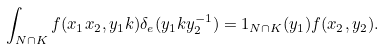Convert formula to latex. <formula><loc_0><loc_0><loc_500><loc_500>\int _ { N \cap K } f ( x _ { 1 } x _ { 2 } , y _ { 1 } k ) \delta _ { e } ( y _ { 1 } k y _ { 2 } ^ { - 1 } ) = 1 _ { N \cap K } ( y _ { 1 } ) f ( x _ { 2 } , y _ { 2 } ) .</formula> 